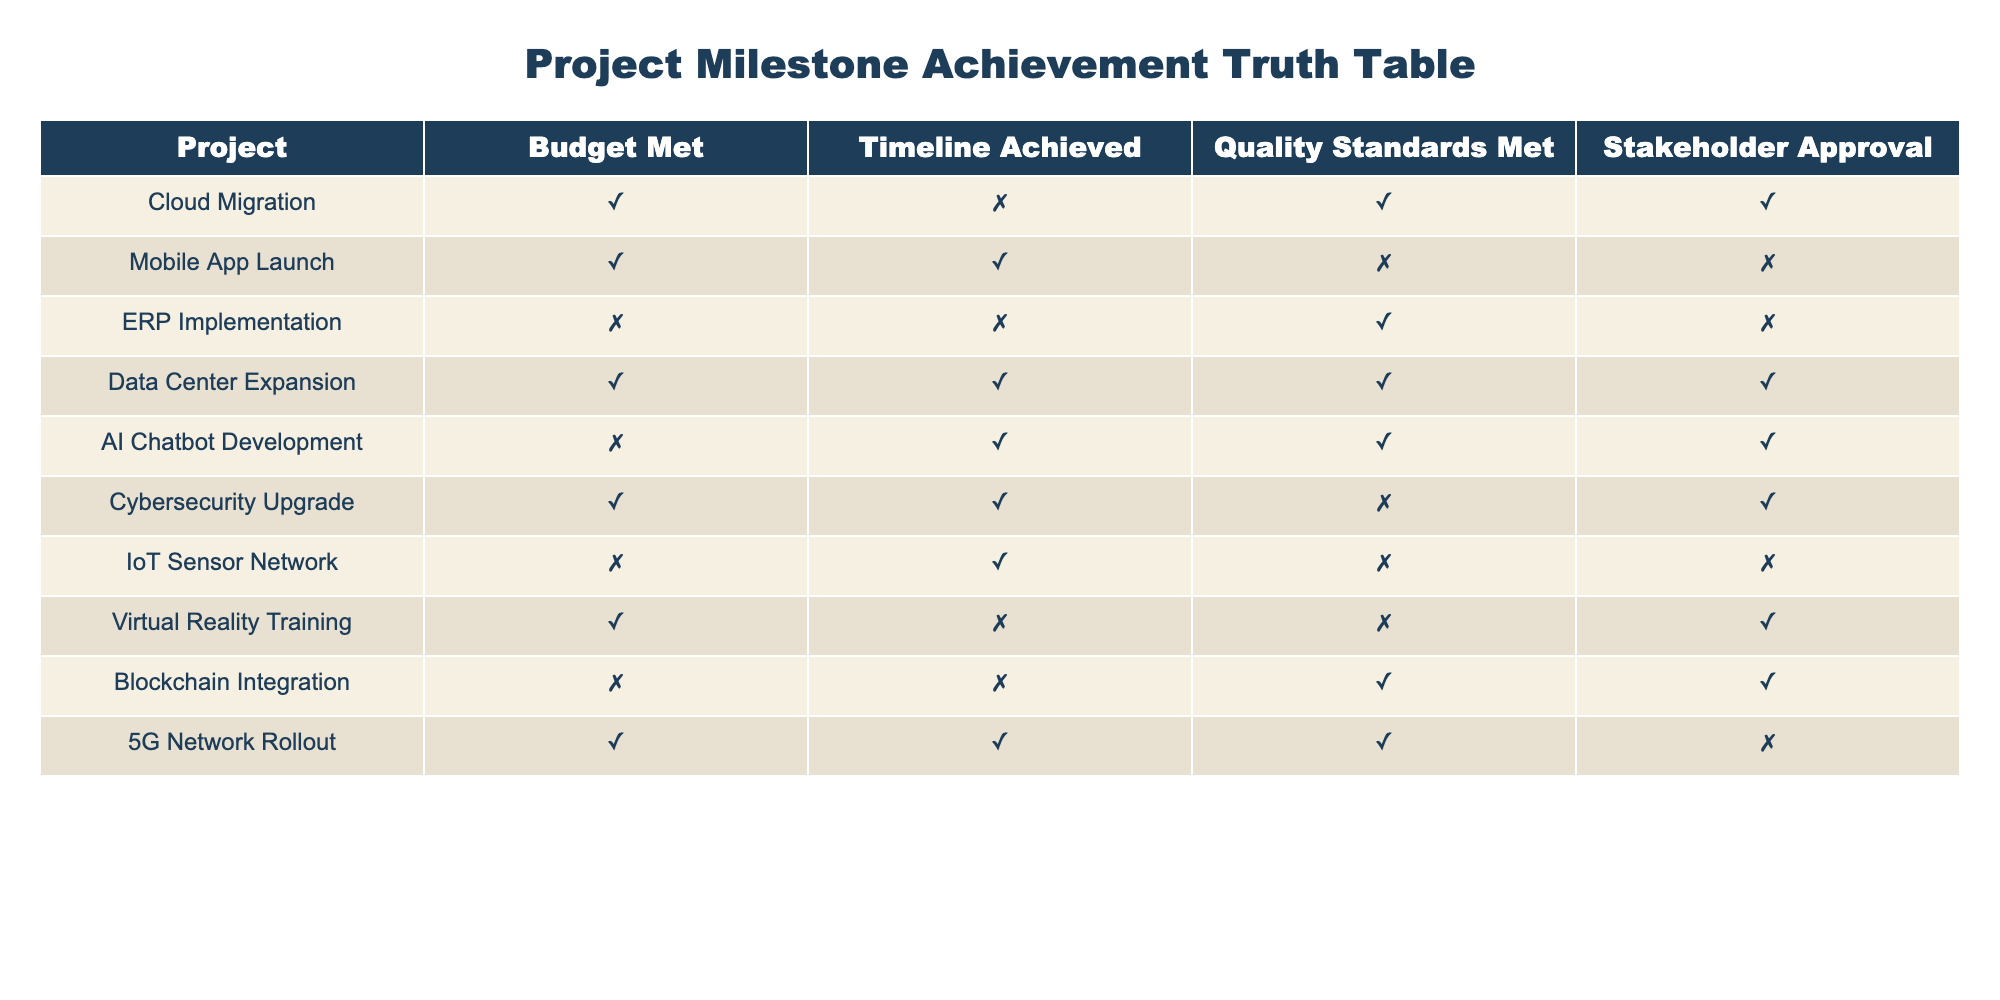What projects achieved both the budget and timeline milestones? To find projects that met both budget and timeline, I look for rows where both "Budget Met" and "Timeline Achieved" are marked TRUE. Analyzing the data, the projects that satisfy this condition are "Mobile App Launch" and "Data Center Expansion."
Answer: Mobile App Launch, Data Center Expansion Which project did not meet the stakeholder approval but achieved the budget and timeline? I check which projects have TRUE under "Budget Met" and "Timeline Achieved" but FALSE under "Stakeholder Approval." The only project that fits this criteria is "Cybersecurity Upgrade."
Answer: Cybersecurity Upgrade How many projects did not meet the timeline milestone? Looking through the table, I count each row that has FALSE in the "Timeline Achieved" column. The projects are "Cloud Migration," "Virtual Reality Training," and "ERP Implementation." So, there are a total of 3 projects.
Answer: 3 Did any projects achieve quality standards but fail to obtain stakeholder approval? I check the "Quality Standards Met" for TRUE entries while looking for corresponding FALSE entries in "Stakeholder Approval." "Blockchain Integration" and "AI Chatbot Development" fulfill these criteria.
Answer: Yes, Blockchain Integration, AI Chatbot Development What is the total count of projects that met all four criteria (budget, timeline, quality, stakeholder approval)? I review each row for projects that have all columns as TRUE. The only project that meets this criterion is "Data Center Expansion." Thus, there is a total of 1 project.
Answer: 1 Which project met the budget but failed the quality standards and stakeholder approval? I identify the project that is TRUE under "Budget Met," but both "Quality Standards Met" and "Stakeholder Approval" are marked FALSE. The project that fits this description is "Mobile App Launch."
Answer: Mobile App Launch Are there more projects that met the budget than those that achieved the timeline? I count the number of "TRUE" entries in the "Budget Met" column, which is 6, and in the "Timeline Achieved" column, which is 5. Comparing the two, 6 is greater than 5, confirming more projects met the budget.
Answer: Yes How many projects achieved both quality standards and stakeholder approval? I look for rows where both "Quality Standards Met" and "Stakeholder Approval" are TRUE. In the data, "Cloud Migration," "AI Chatbot Development," and "Blockchain Integration" meet both conditions. Therefore, there are a total of 3 such projects.
Answer: 3 